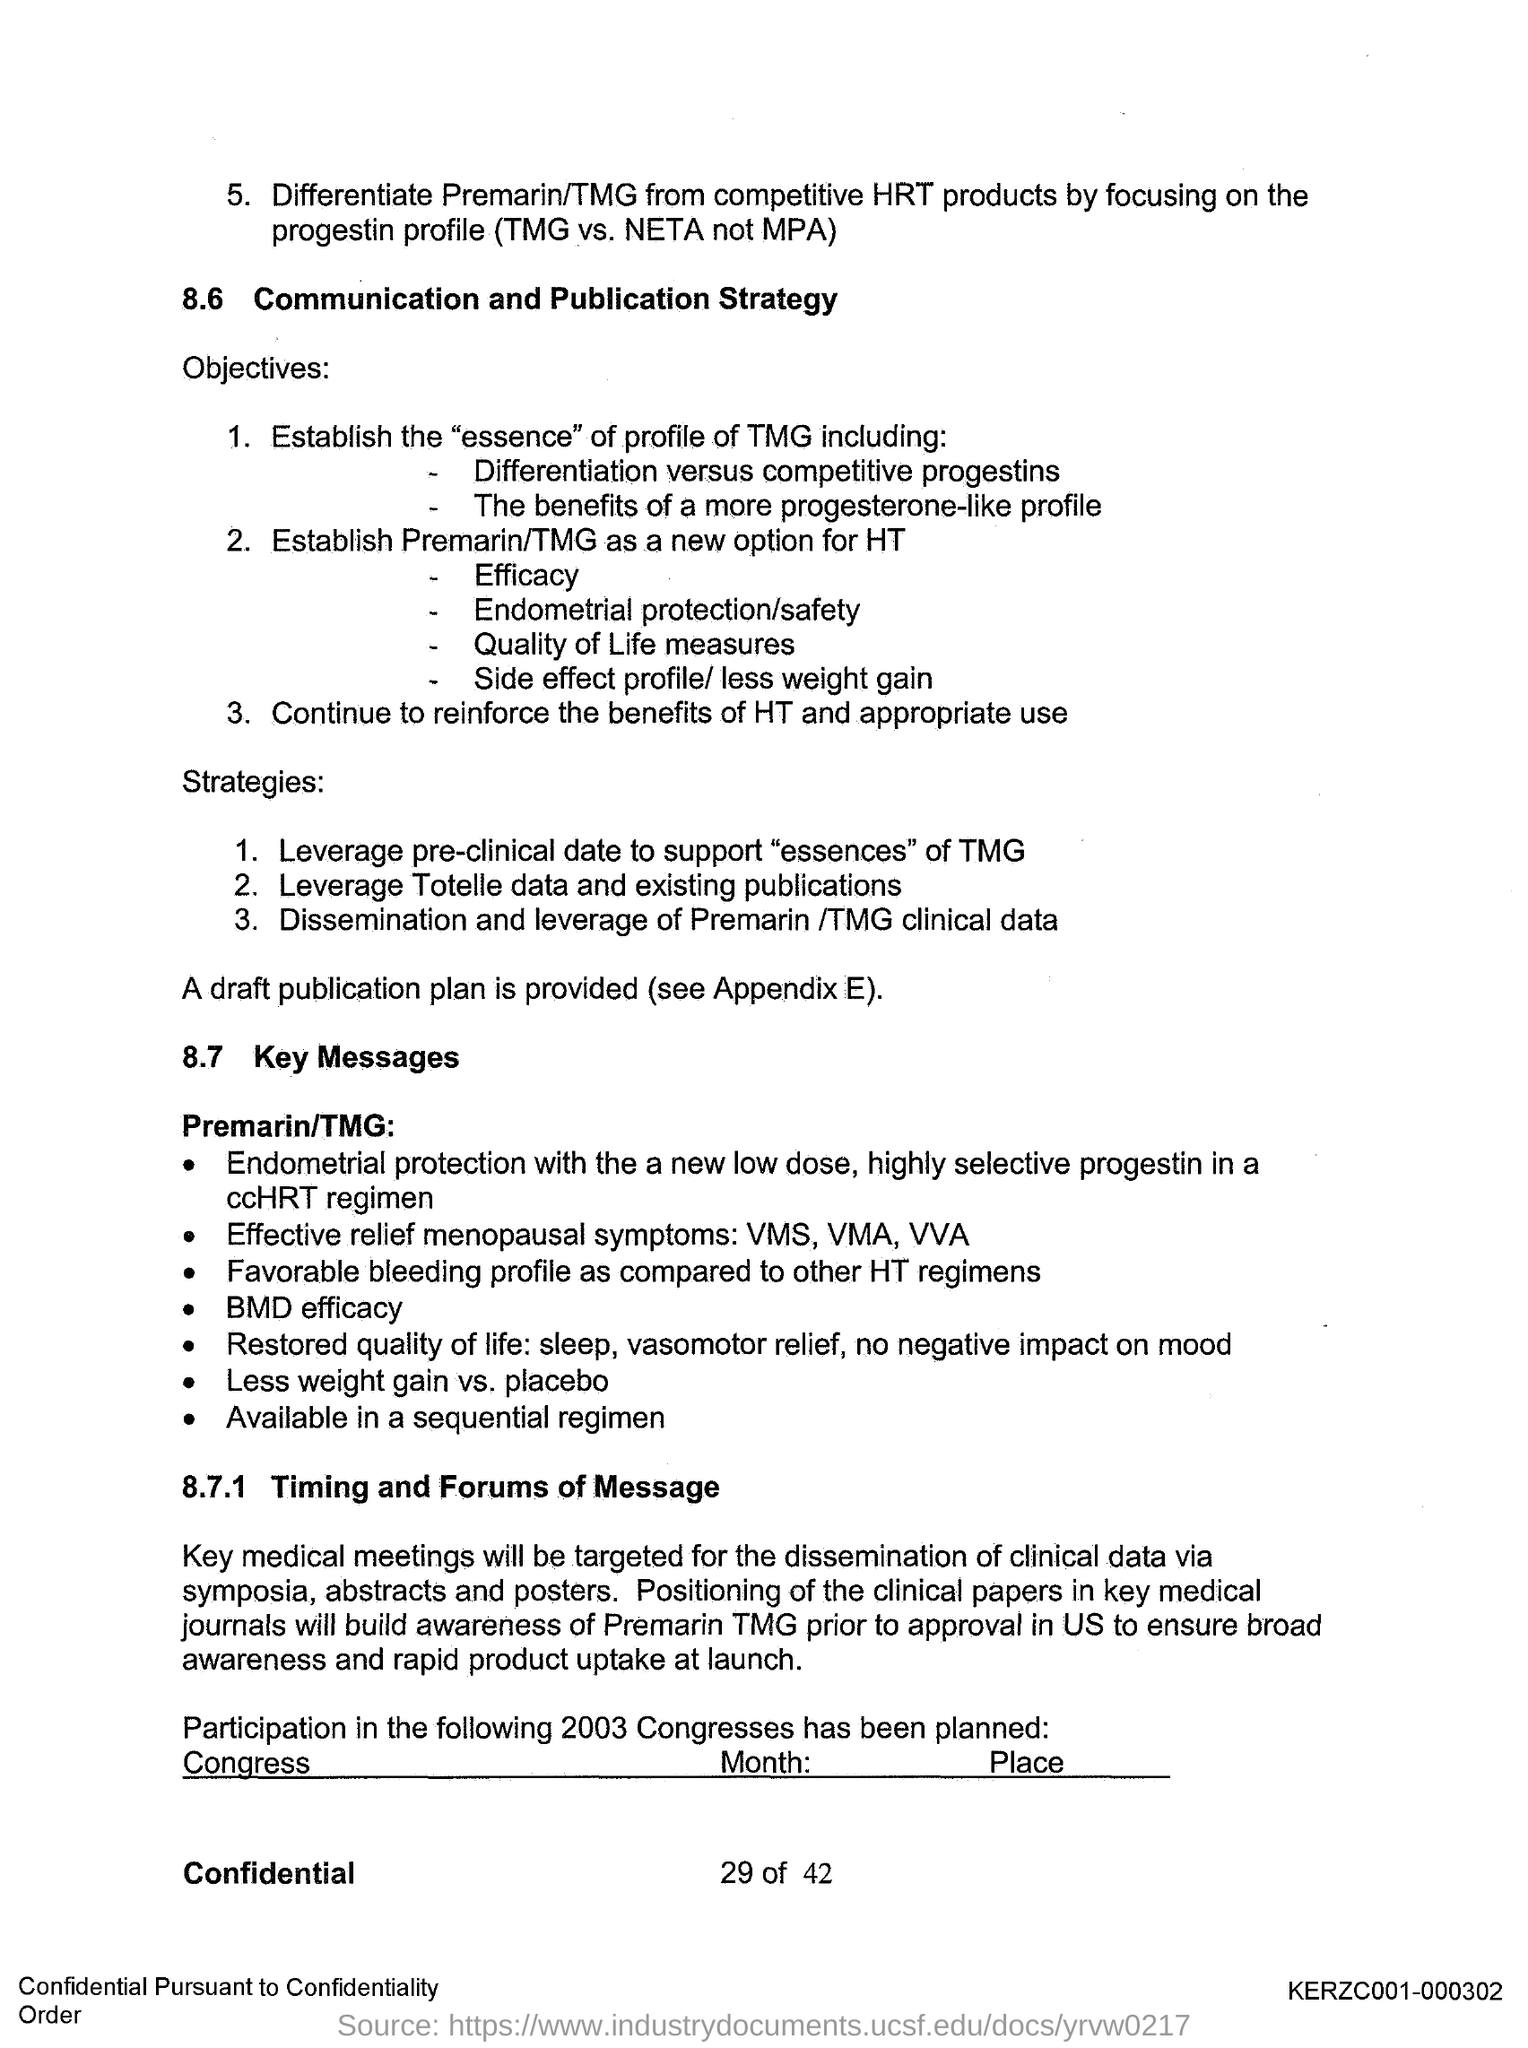Outline some significant characteristics in this image. The first title in the document is "Communication and publication strategy. The second title in the document is 'KEY MESSAGES.' 